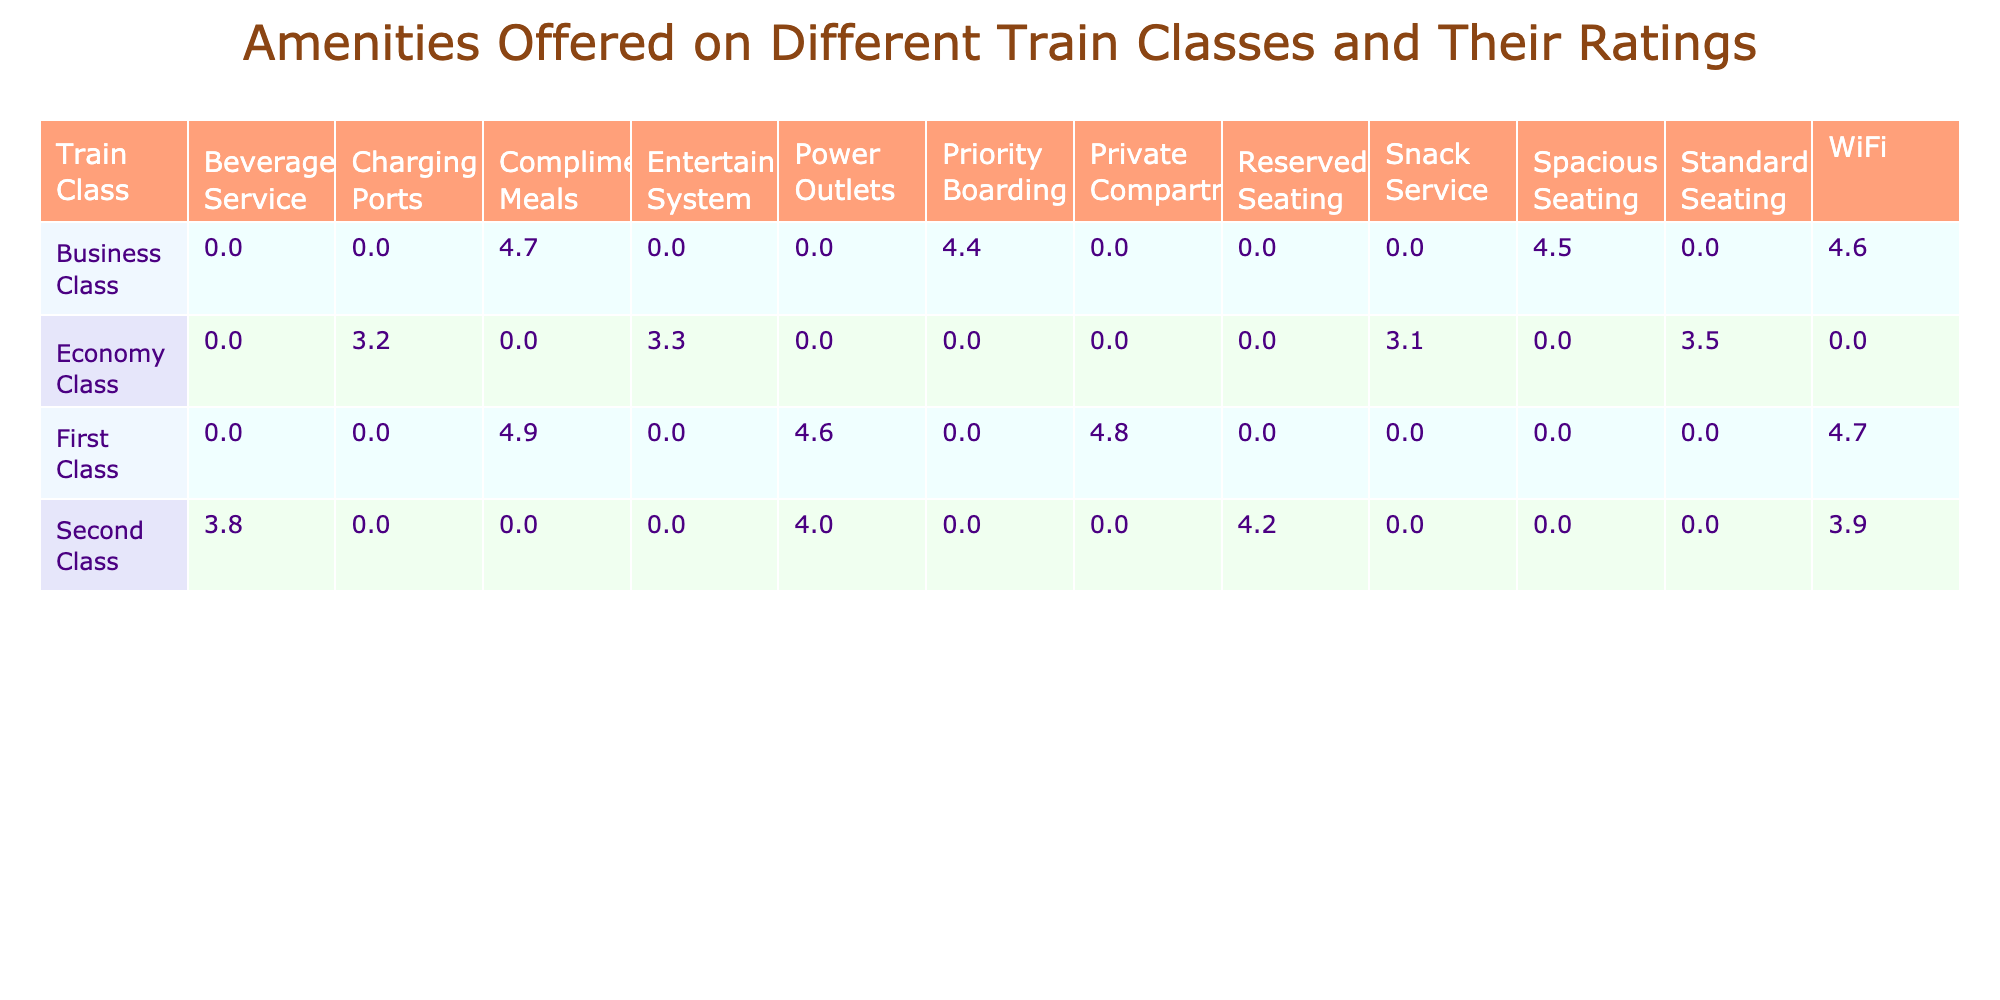What is the highest rating for amenities in First Class? The table shows that the highest rating for amenities in First Class is for Complimentary Meals, which has a rating of 4.9.
Answer: 4.9 Which class offers Complimentary Meals and what is its rating? Complimentary Meals are offered in both First Class and Business Class. The rating for First Class is 4.9, while the rating for Business Class is 4.7.
Answer: First Class: 4.9, Business Class: 4.7 What is the average rating for amenities in Economy Class? The ratings for Economy Class amenities are 3.5 (Standard Seating), 3.3 (Entertainment System), 3.2 (Charging Ports), and 3.1 (Snack Service). Adding them gives a total of 13.1, and there are 4 amenities, so the average rating is 13.1 / 4 = 3.275.
Answer: 3.275 Is WiFi offered in every train class? Yes, WiFi is listed under the amenities for First Class, Second Class, and Business Class, so it is offered in every train class.
Answer: Yes Which train class has the lowest rating for Power Outlets? The table shows that the lowest rating for Power Outlets is in Second Class with a rating of 4.0, while in First Class it is 4.6 and in Business Class it is not listed.
Answer: 4.0 (Second Class) What is the difference in ratings for Reserved Seating between Second Class and Business Class? Reserved Seating is not available in Business Class, so it has no rating. The rating for Second Class's Reserved Seating is 4.2. The difference is calculated as 4.2 - 0 = 4.2.
Answer: 4.2 Which train class has the highest average rating for all amenities combined? First Class has ratings of 4.8, 4.7, 4.9, and 4.6, summing up to 19 and averaging to 19 / 4 = 4.75. Business Class has a total of 4.6, 4.5, 4.7, and 4.4, summing to 18.2 and averaging 18.2 / 4 = 4.55. Comparatively, First Class has the higher average.
Answer: First Class Is the rating for Charging Ports higher than the average rating for Second Class amenities? The average rating for Second Class amenities is (4.2 + 3.9 + 3.8 + 4.0) / 4 = 4.0. The rating for Charging Ports in Economy Class is 3.2, which is lower than the average rating for Second Class.
Answer: No What is the total number of unique amenities offered across all classes? By looking at the different amenities listed, we find Private Compartment, WiFi, Complimentary Meals, Power Outlets, Reserved Seating, Beverage Service, Standard Seating, Entertainment System, Charging Ports, Snack Service, Spacious Seating, and Priority Boarding. That totals 12 unique amenities.
Answer: 12 